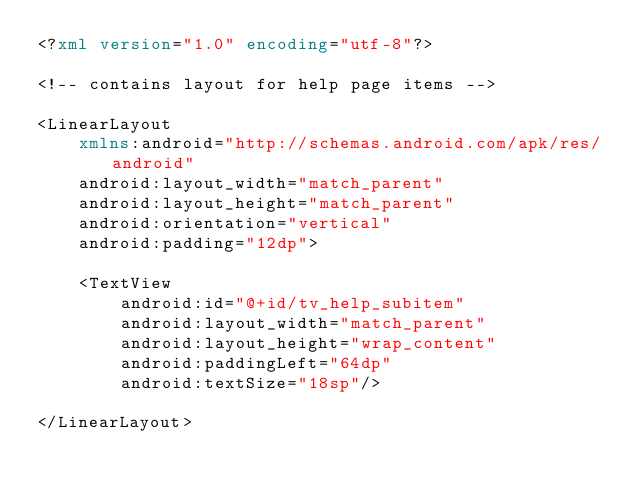<code> <loc_0><loc_0><loc_500><loc_500><_XML_><?xml version="1.0" encoding="utf-8"?>

<!-- contains layout for help page items -->

<LinearLayout
    xmlns:android="http://schemas.android.com/apk/res/android"
    android:layout_width="match_parent"
    android:layout_height="match_parent"
    android:orientation="vertical"
    android:padding="12dp">

    <TextView
        android:id="@+id/tv_help_subitem"
        android:layout_width="match_parent"
        android:layout_height="wrap_content"
        android:paddingLeft="64dp"
        android:textSize="18sp"/>

</LinearLayout></code> 